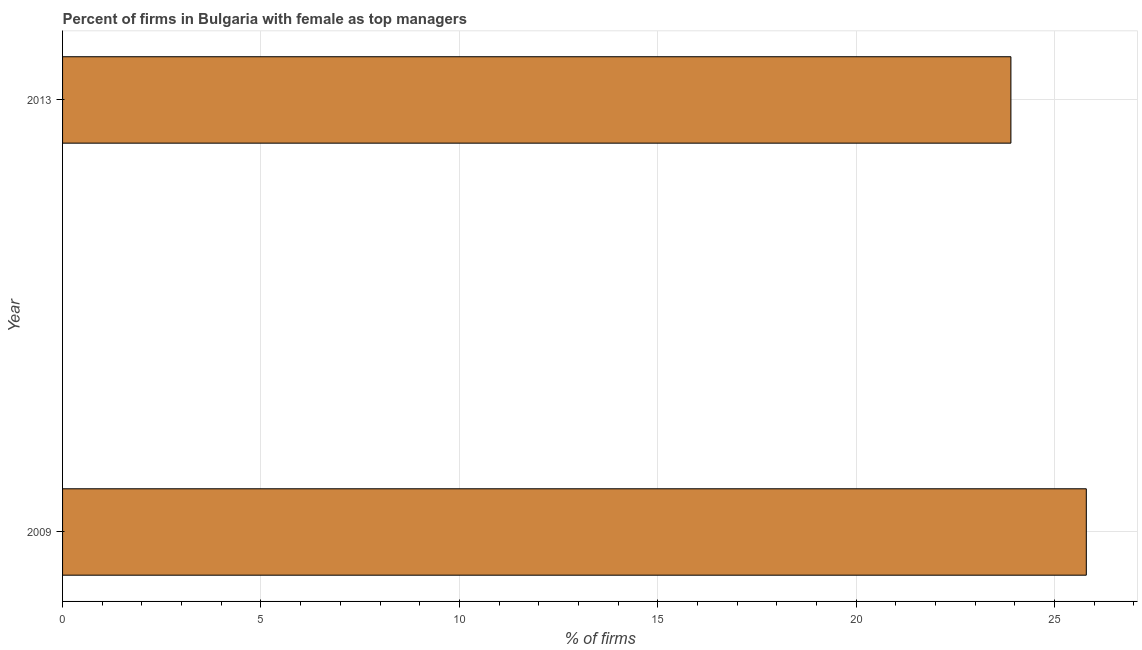Does the graph contain grids?
Offer a terse response. Yes. What is the title of the graph?
Ensure brevity in your answer.  Percent of firms in Bulgaria with female as top managers. What is the label or title of the X-axis?
Your response must be concise. % of firms. What is the percentage of firms with female as top manager in 2013?
Keep it short and to the point. 23.9. Across all years, what is the maximum percentage of firms with female as top manager?
Your answer should be compact. 25.8. Across all years, what is the minimum percentage of firms with female as top manager?
Ensure brevity in your answer.  23.9. In which year was the percentage of firms with female as top manager minimum?
Offer a terse response. 2013. What is the sum of the percentage of firms with female as top manager?
Keep it short and to the point. 49.7. What is the average percentage of firms with female as top manager per year?
Your answer should be very brief. 24.85. What is the median percentage of firms with female as top manager?
Offer a terse response. 24.85. In how many years, is the percentage of firms with female as top manager greater than 7 %?
Ensure brevity in your answer.  2. Do a majority of the years between 2009 and 2013 (inclusive) have percentage of firms with female as top manager greater than 20 %?
Your response must be concise. Yes. What is the ratio of the percentage of firms with female as top manager in 2009 to that in 2013?
Your answer should be very brief. 1.08. Is the percentage of firms with female as top manager in 2009 less than that in 2013?
Provide a succinct answer. No. In how many years, is the percentage of firms with female as top manager greater than the average percentage of firms with female as top manager taken over all years?
Ensure brevity in your answer.  1. How many years are there in the graph?
Provide a short and direct response. 2. What is the % of firms of 2009?
Offer a terse response. 25.8. What is the % of firms in 2013?
Provide a succinct answer. 23.9. What is the ratio of the % of firms in 2009 to that in 2013?
Provide a short and direct response. 1.08. 